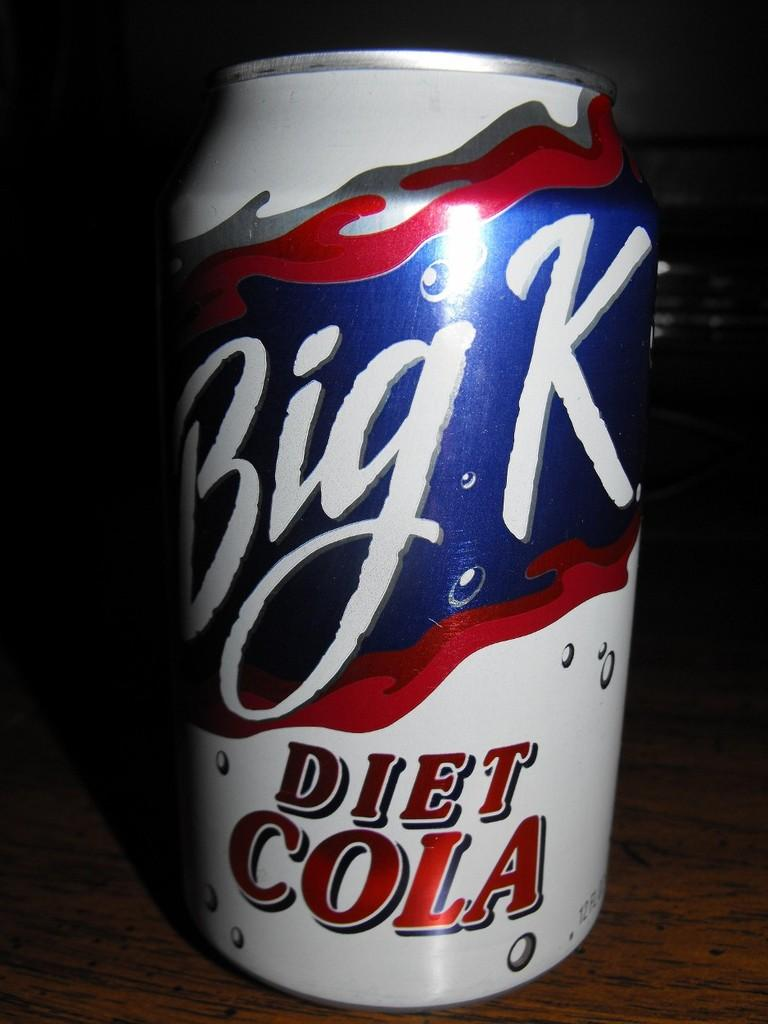<image>
Render a clear and concise summary of the photo. A can of Big K Diet Cola from a Kroger store. 